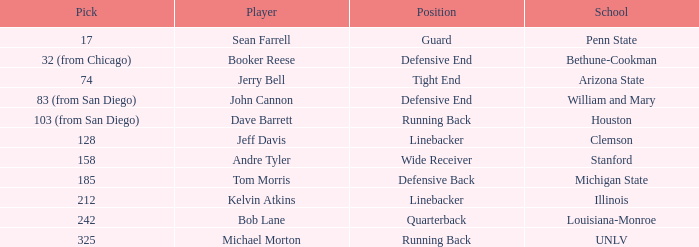What pick did Clemson choose? 128.0. 